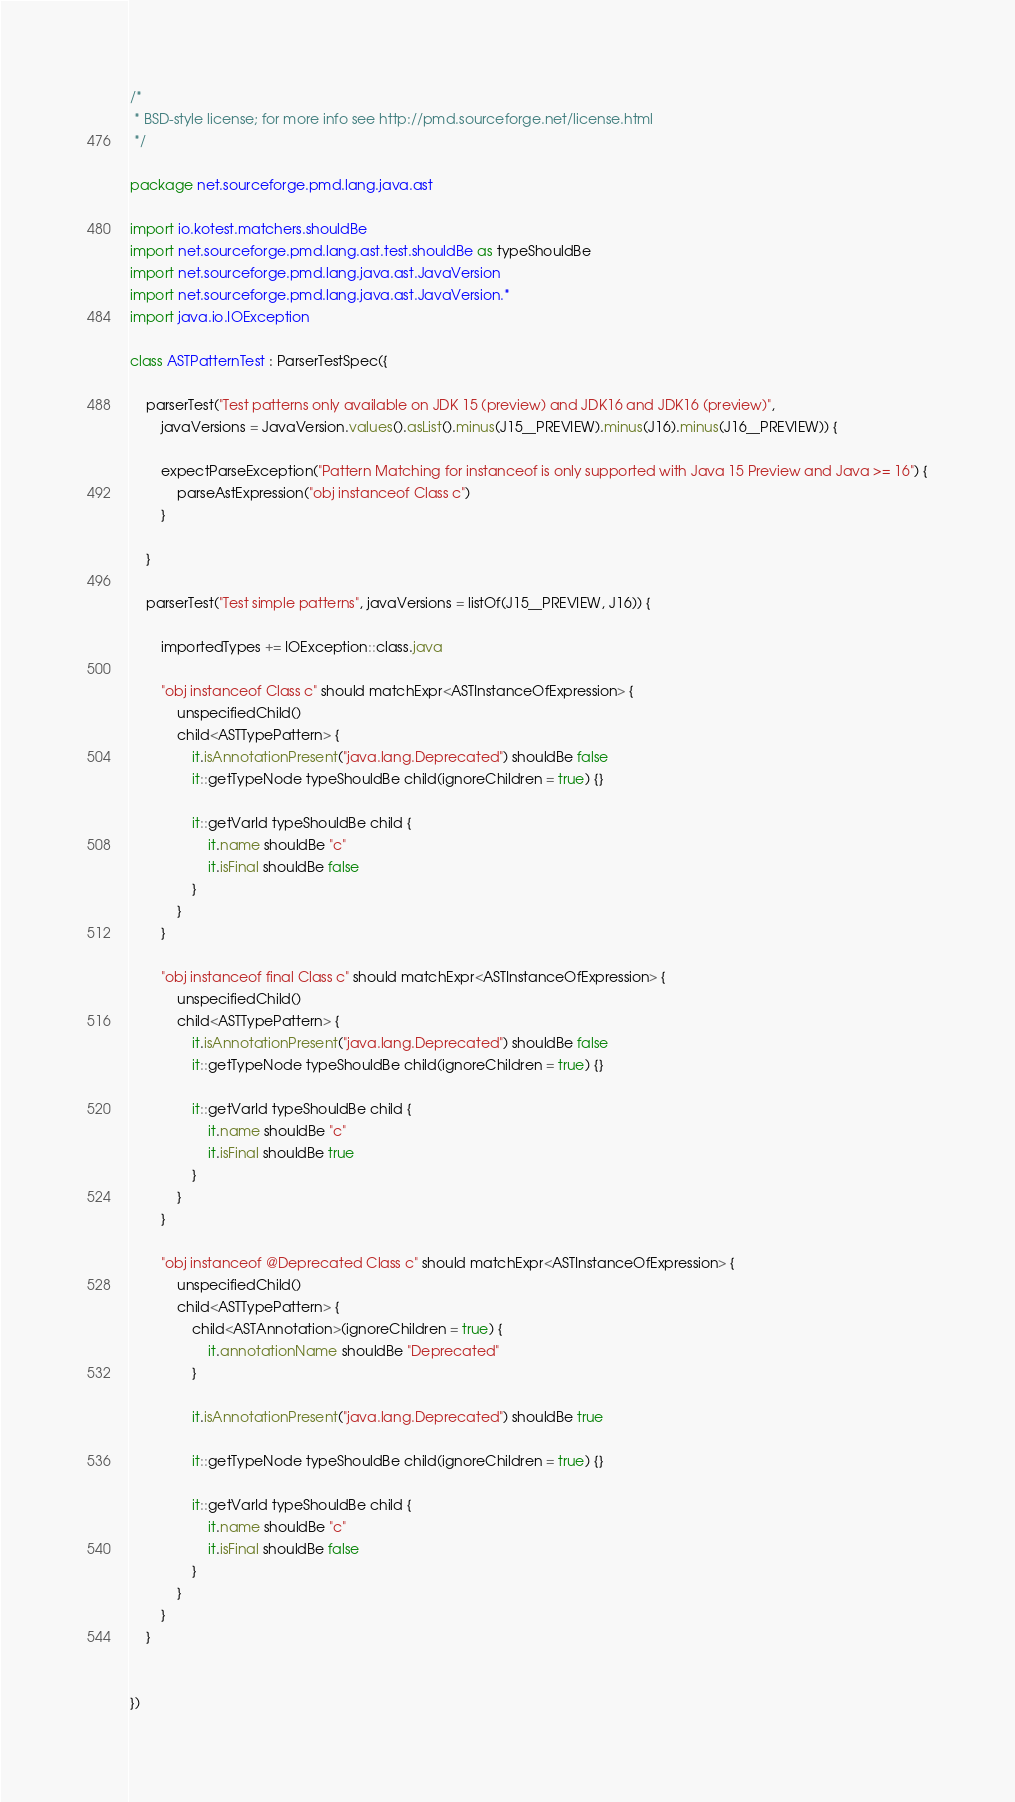<code> <loc_0><loc_0><loc_500><loc_500><_Kotlin_>/*
 * BSD-style license; for more info see http://pmd.sourceforge.net/license.html
 */

package net.sourceforge.pmd.lang.java.ast

import io.kotest.matchers.shouldBe
import net.sourceforge.pmd.lang.ast.test.shouldBe as typeShouldBe
import net.sourceforge.pmd.lang.java.ast.JavaVersion
import net.sourceforge.pmd.lang.java.ast.JavaVersion.*
import java.io.IOException

class ASTPatternTest : ParserTestSpec({

    parserTest("Test patterns only available on JDK 15 (preview) and JDK16 and JDK16 (preview)",
        javaVersions = JavaVersion.values().asList().minus(J15__PREVIEW).minus(J16).minus(J16__PREVIEW)) {

        expectParseException("Pattern Matching for instanceof is only supported with Java 15 Preview and Java >= 16") {
            parseAstExpression("obj instanceof Class c")
        }

    }

    parserTest("Test simple patterns", javaVersions = listOf(J15__PREVIEW, J16)) {

        importedTypes += IOException::class.java

        "obj instanceof Class c" should matchExpr<ASTInstanceOfExpression> {
            unspecifiedChild()
            child<ASTTypePattern> {
                it.isAnnotationPresent("java.lang.Deprecated") shouldBe false
                it::getTypeNode typeShouldBe child(ignoreChildren = true) {}

                it::getVarId typeShouldBe child {
                    it.name shouldBe "c"
                    it.isFinal shouldBe false
                }
            }
        }

        "obj instanceof final Class c" should matchExpr<ASTInstanceOfExpression> {
            unspecifiedChild()
            child<ASTTypePattern> {
                it.isAnnotationPresent("java.lang.Deprecated") shouldBe false
                it::getTypeNode typeShouldBe child(ignoreChildren = true) {}

                it::getVarId typeShouldBe child {
                    it.name shouldBe "c"
                    it.isFinal shouldBe true
                }
            }
        }

        "obj instanceof @Deprecated Class c" should matchExpr<ASTInstanceOfExpression> {
            unspecifiedChild()
            child<ASTTypePattern> {
                child<ASTAnnotation>(ignoreChildren = true) {
                    it.annotationName shouldBe "Deprecated"
                }

                it.isAnnotationPresent("java.lang.Deprecated") shouldBe true

                it::getTypeNode typeShouldBe child(ignoreChildren = true) {}

                it::getVarId typeShouldBe child {
                    it.name shouldBe "c"
                    it.isFinal shouldBe false
                }
            }
        }
    }


})
</code> 